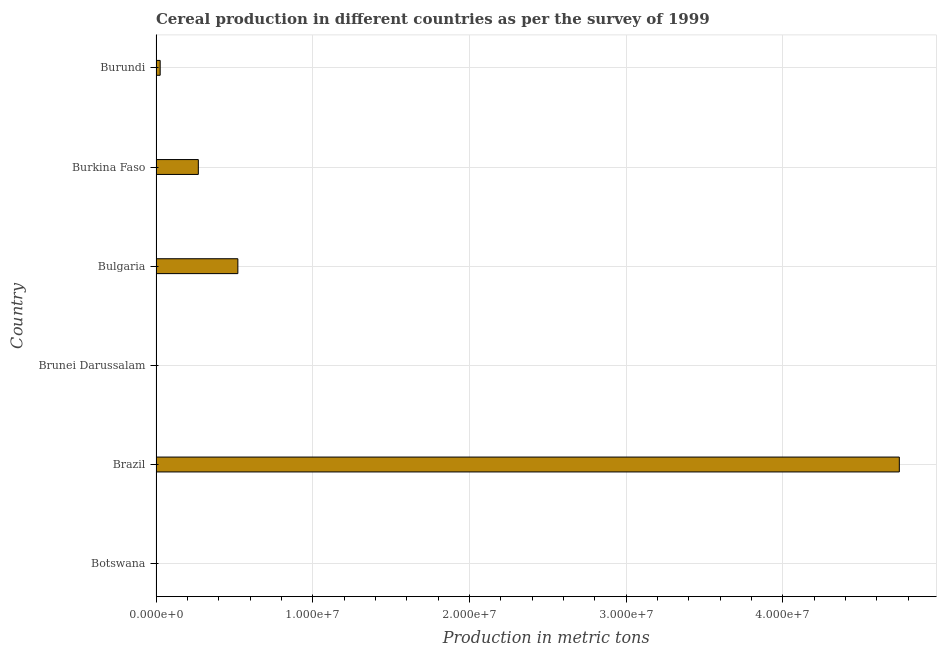Does the graph contain any zero values?
Your answer should be very brief. No. What is the title of the graph?
Offer a terse response. Cereal production in different countries as per the survey of 1999. What is the label or title of the X-axis?
Offer a very short reply. Production in metric tons. What is the label or title of the Y-axis?
Offer a terse response. Country. What is the cereal production in Burundi?
Ensure brevity in your answer.  2.65e+05. Across all countries, what is the maximum cereal production?
Your answer should be compact. 4.74e+07. Across all countries, what is the minimum cereal production?
Your answer should be compact. 200. In which country was the cereal production minimum?
Your response must be concise. Brunei Darussalam. What is the sum of the cereal production?
Provide a short and direct response. 5.56e+07. What is the difference between the cereal production in Botswana and Burundi?
Give a very brief answer. -2.44e+05. What is the average cereal production per country?
Ensure brevity in your answer.  9.27e+06. What is the median cereal production?
Ensure brevity in your answer.  1.48e+06. What is the ratio of the cereal production in Botswana to that in Bulgaria?
Keep it short and to the point. 0. Is the difference between the cereal production in Botswana and Brunei Darussalam greater than the difference between any two countries?
Give a very brief answer. No. What is the difference between the highest and the second highest cereal production?
Give a very brief answer. 4.22e+07. Is the sum of the cereal production in Botswana and Bulgaria greater than the maximum cereal production across all countries?
Give a very brief answer. No. What is the difference between the highest and the lowest cereal production?
Provide a short and direct response. 4.74e+07. Are all the bars in the graph horizontal?
Ensure brevity in your answer.  Yes. What is the difference between two consecutive major ticks on the X-axis?
Offer a terse response. 1.00e+07. What is the Production in metric tons of Botswana?
Ensure brevity in your answer.  2.06e+04. What is the Production in metric tons in Brazil?
Your answer should be very brief. 4.74e+07. What is the Production in metric tons in Brunei Darussalam?
Your answer should be very brief. 200. What is the Production in metric tons in Bulgaria?
Make the answer very short. 5.22e+06. What is the Production in metric tons in Burkina Faso?
Offer a terse response. 2.70e+06. What is the Production in metric tons in Burundi?
Offer a terse response. 2.65e+05. What is the difference between the Production in metric tons in Botswana and Brazil?
Ensure brevity in your answer.  -4.74e+07. What is the difference between the Production in metric tons in Botswana and Brunei Darussalam?
Give a very brief answer. 2.04e+04. What is the difference between the Production in metric tons in Botswana and Bulgaria?
Your response must be concise. -5.20e+06. What is the difference between the Production in metric tons in Botswana and Burkina Faso?
Your response must be concise. -2.68e+06. What is the difference between the Production in metric tons in Botswana and Burundi?
Give a very brief answer. -2.44e+05. What is the difference between the Production in metric tons in Brazil and Brunei Darussalam?
Your response must be concise. 4.74e+07. What is the difference between the Production in metric tons in Brazil and Bulgaria?
Provide a short and direct response. 4.22e+07. What is the difference between the Production in metric tons in Brazil and Burkina Faso?
Ensure brevity in your answer.  4.47e+07. What is the difference between the Production in metric tons in Brazil and Burundi?
Offer a very short reply. 4.72e+07. What is the difference between the Production in metric tons in Brunei Darussalam and Bulgaria?
Give a very brief answer. -5.22e+06. What is the difference between the Production in metric tons in Brunei Darussalam and Burkina Faso?
Ensure brevity in your answer.  -2.70e+06. What is the difference between the Production in metric tons in Brunei Darussalam and Burundi?
Provide a succinct answer. -2.64e+05. What is the difference between the Production in metric tons in Bulgaria and Burkina Faso?
Ensure brevity in your answer.  2.52e+06. What is the difference between the Production in metric tons in Bulgaria and Burundi?
Ensure brevity in your answer.  4.96e+06. What is the difference between the Production in metric tons in Burkina Faso and Burundi?
Provide a short and direct response. 2.44e+06. What is the ratio of the Production in metric tons in Botswana to that in Brunei Darussalam?
Offer a terse response. 102.89. What is the ratio of the Production in metric tons in Botswana to that in Bulgaria?
Offer a terse response. 0. What is the ratio of the Production in metric tons in Botswana to that in Burkina Faso?
Your response must be concise. 0.01. What is the ratio of the Production in metric tons in Botswana to that in Burundi?
Ensure brevity in your answer.  0.08. What is the ratio of the Production in metric tons in Brazil to that in Brunei Darussalam?
Provide a succinct answer. 2.37e+05. What is the ratio of the Production in metric tons in Brazil to that in Bulgaria?
Give a very brief answer. 9.08. What is the ratio of the Production in metric tons in Brazil to that in Burkina Faso?
Your answer should be compact. 17.57. What is the ratio of the Production in metric tons in Brazil to that in Burundi?
Your answer should be compact. 179.3. What is the ratio of the Production in metric tons in Brunei Darussalam to that in Bulgaria?
Ensure brevity in your answer.  0. What is the ratio of the Production in metric tons in Brunei Darussalam to that in Burkina Faso?
Offer a very short reply. 0. What is the ratio of the Production in metric tons in Bulgaria to that in Burkina Faso?
Make the answer very short. 1.93. What is the ratio of the Production in metric tons in Bulgaria to that in Burundi?
Provide a succinct answer. 19.74. What is the ratio of the Production in metric tons in Burkina Faso to that in Burundi?
Your answer should be compact. 10.21. 